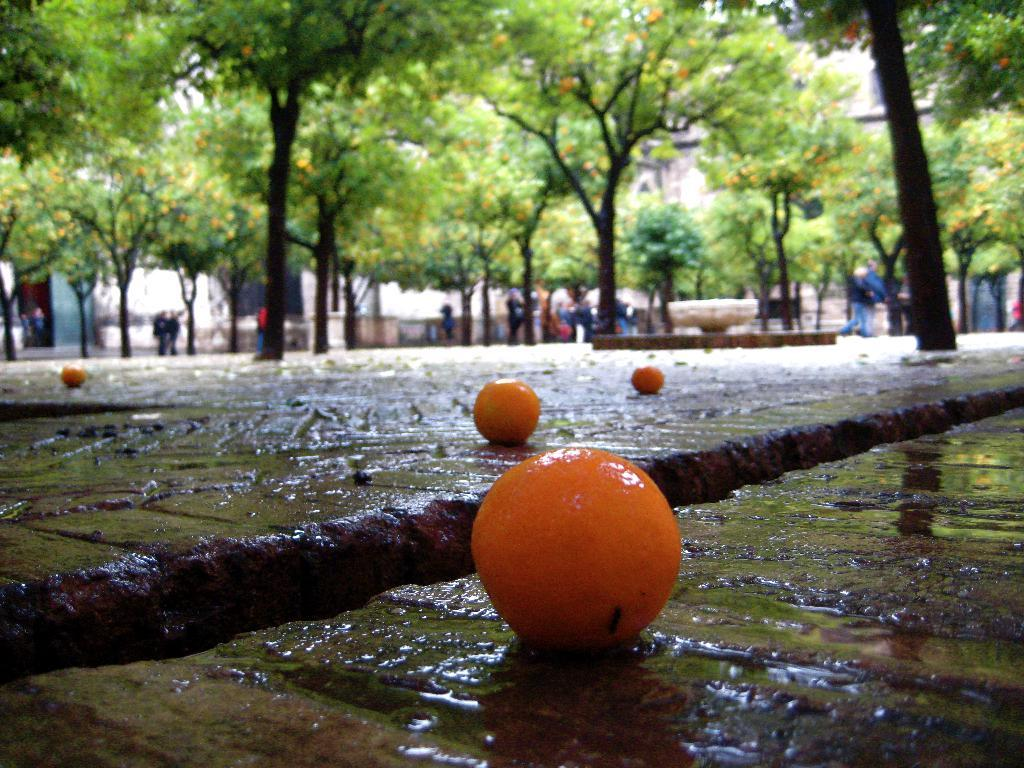What type of fruit can be seen on the ground in the image? There are oranges on the ground in the image. What else is present on the ground in the image? There is water on the ground in the image. What structure is visible in the image? There is a fountain in the image. What type of vegetation is present in the image? There are trees in the image. What type of man-made structure is visible in the image? There is a building in the image. Can you describe the people in the image? There is a group of people standing in the image. What type of scent can be detected from the oranges in the image? There is no indication of scent in the image, as it is a visual representation. What type of badge is being worn by the people in the image? There is no mention of badges or any specific clothing items in the image. 